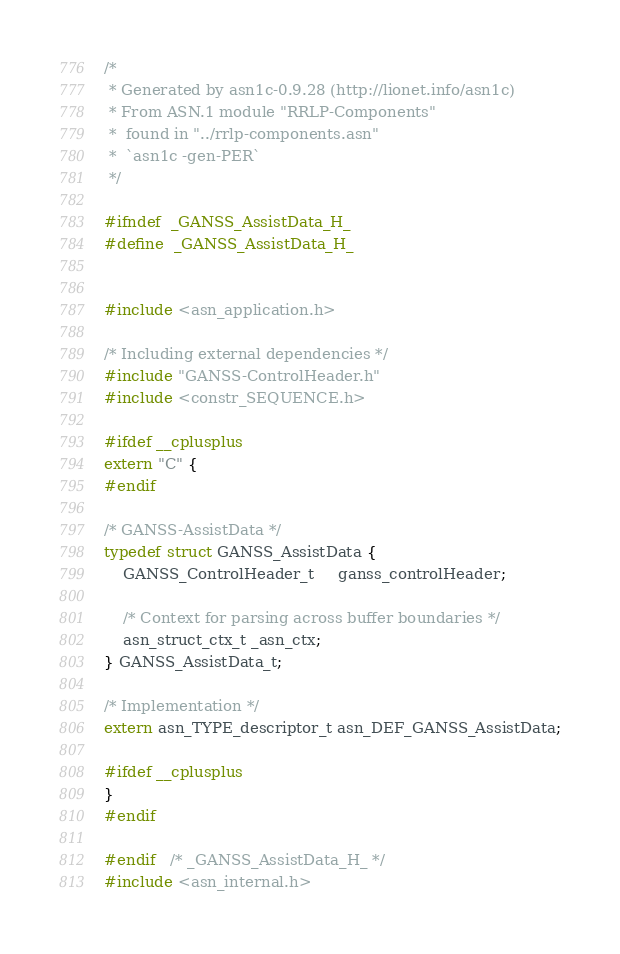Convert code to text. <code><loc_0><loc_0><loc_500><loc_500><_C_>/*
 * Generated by asn1c-0.9.28 (http://lionet.info/asn1c)
 * From ASN.1 module "RRLP-Components"
 * 	found in "../rrlp-components.asn"
 * 	`asn1c -gen-PER`
 */

#ifndef	_GANSS_AssistData_H_
#define	_GANSS_AssistData_H_


#include <asn_application.h>

/* Including external dependencies */
#include "GANSS-ControlHeader.h"
#include <constr_SEQUENCE.h>

#ifdef __cplusplus
extern "C" {
#endif

/* GANSS-AssistData */
typedef struct GANSS_AssistData {
	GANSS_ControlHeader_t	 ganss_controlHeader;
	
	/* Context for parsing across buffer boundaries */
	asn_struct_ctx_t _asn_ctx;
} GANSS_AssistData_t;

/* Implementation */
extern asn_TYPE_descriptor_t asn_DEF_GANSS_AssistData;

#ifdef __cplusplus
}
#endif

#endif	/* _GANSS_AssistData_H_ */
#include <asn_internal.h>
</code> 